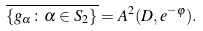Convert formula to latex. <formula><loc_0><loc_0><loc_500><loc_500>\overline { \{ g _ { \alpha } \colon \alpha \in S _ { 2 } \} } = A ^ { 2 } ( D , e ^ { - \varphi } ) .</formula> 